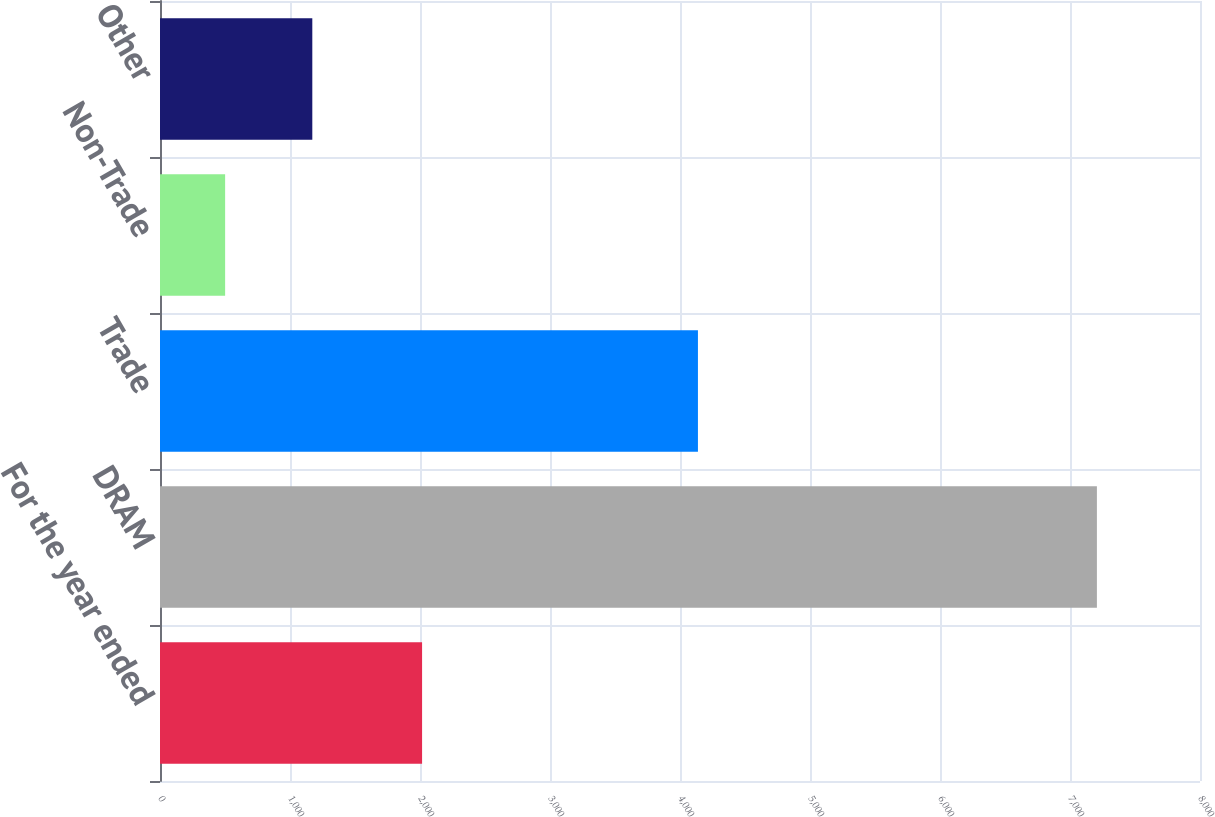<chart> <loc_0><loc_0><loc_500><loc_500><bar_chart><fcel>For the year ended<fcel>DRAM<fcel>Trade<fcel>Non-Trade<fcel>Other<nl><fcel>2016<fcel>7207<fcel>4138<fcel>501<fcel>1171.6<nl></chart> 